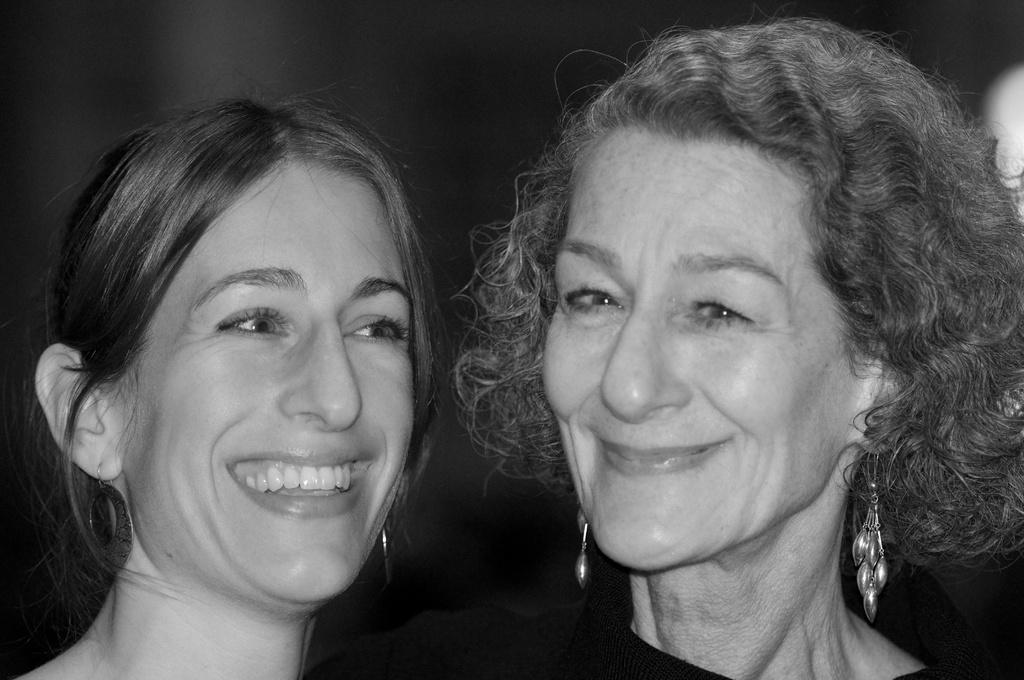What is the color scheme of the image? The image is black and white. How many people are present in the image? There are two persons in the image. What expressions do the people have on their faces? Both persons are wearing a smile on their faces. Can you see a zebra in the image? No, there is no zebra present in the image. Is there a camp visible in the background of the image? The provided facts do not mention a camp or any background details, so it cannot be determined from the image. 